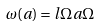Convert formula to latex. <formula><loc_0><loc_0><loc_500><loc_500>\omega ( a ) = l { \Omega } { a \Omega }</formula> 